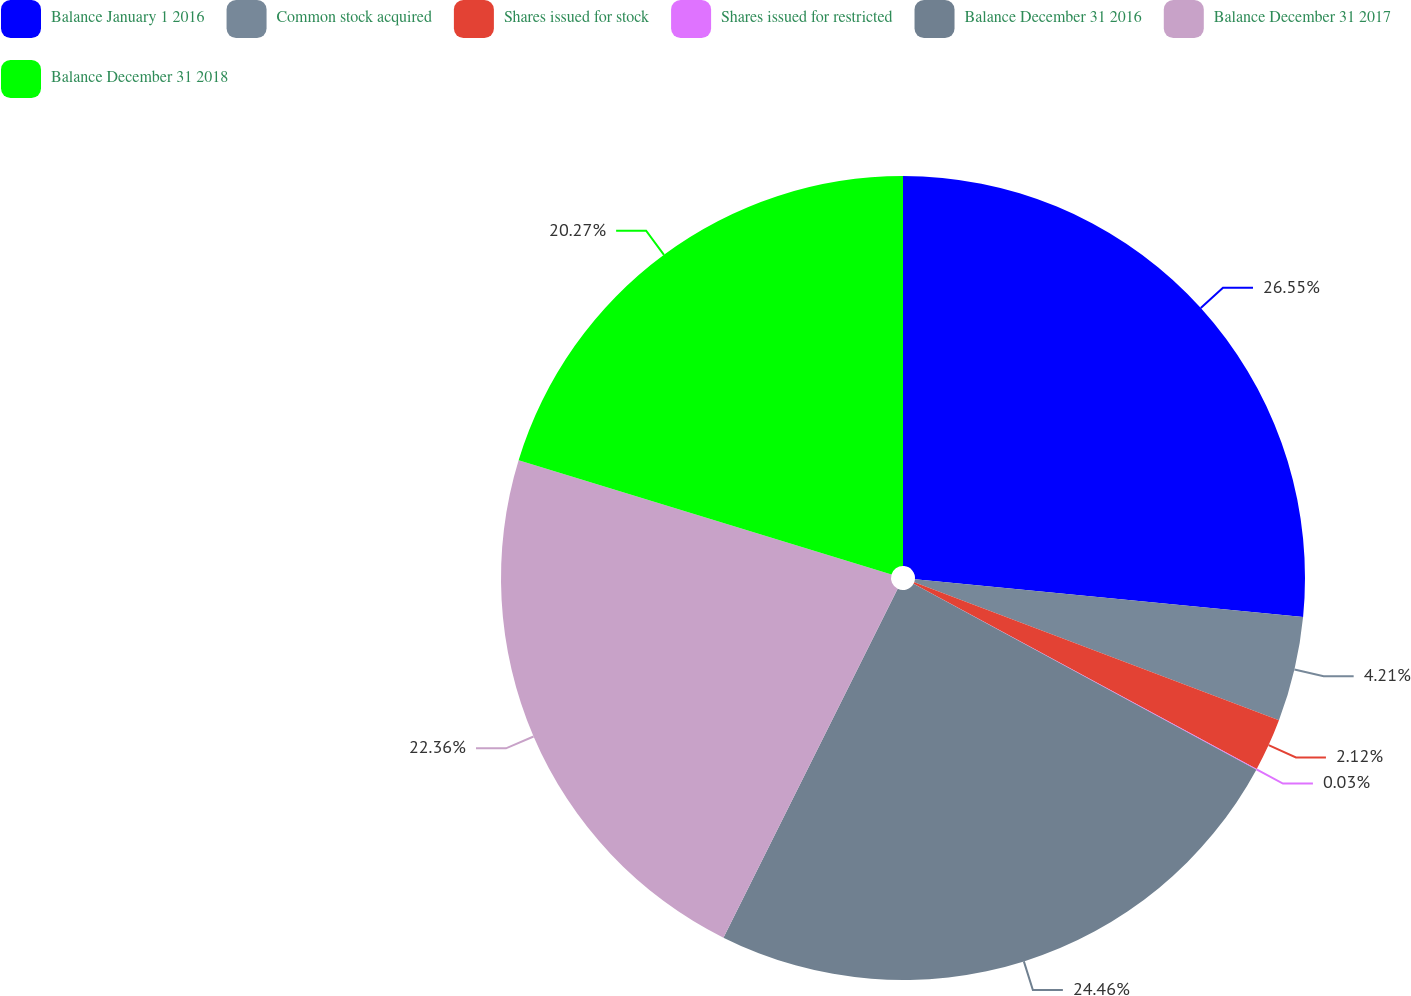<chart> <loc_0><loc_0><loc_500><loc_500><pie_chart><fcel>Balance January 1 2016<fcel>Common stock acquired<fcel>Shares issued for stock<fcel>Shares issued for restricted<fcel>Balance December 31 2016<fcel>Balance December 31 2017<fcel>Balance December 31 2018<nl><fcel>26.55%<fcel>4.21%<fcel>2.12%<fcel>0.03%<fcel>24.46%<fcel>22.36%<fcel>20.27%<nl></chart> 